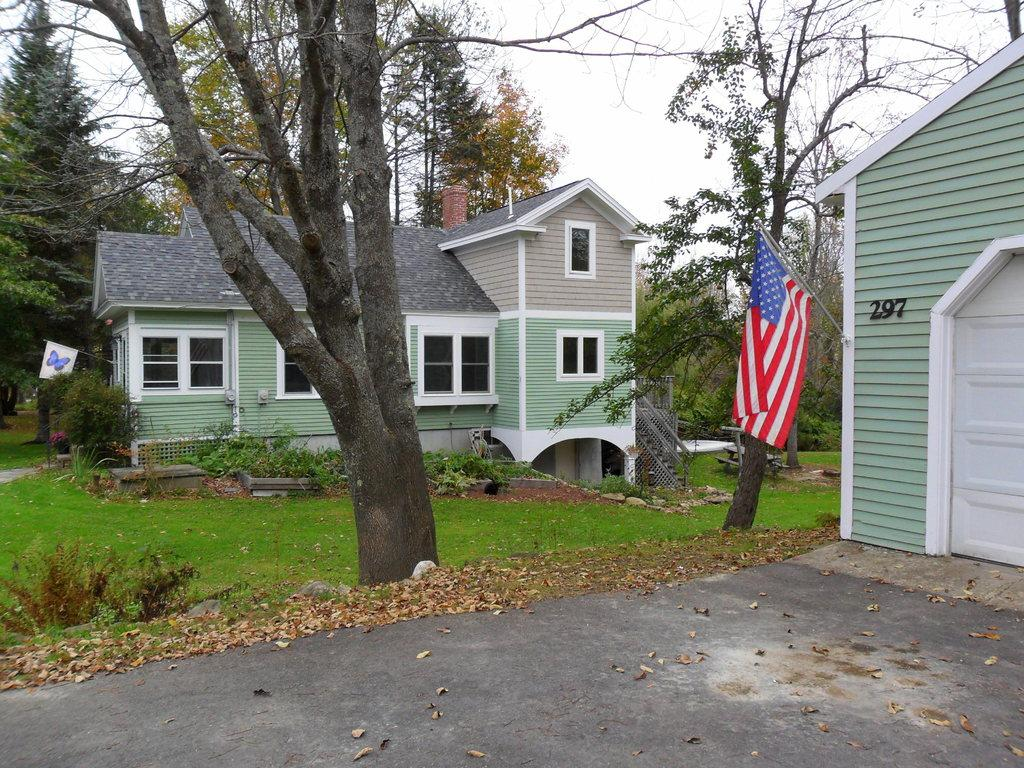What can be seen flying or waving in the image? There is a flag in the image. What type of structures are visible in the image? There are houses in the image. What kind of vegetation is present in the image? There are trees with green color in the image. What is the color of the sky in the image? The sky is white in color. How does the zebra interact with the society in the image? There is no zebra present in the image, so it cannot interact with any society. What method is used to sort the houses in the image? There is no sorting method mentioned or implied in the image; the houses are simply visible. 